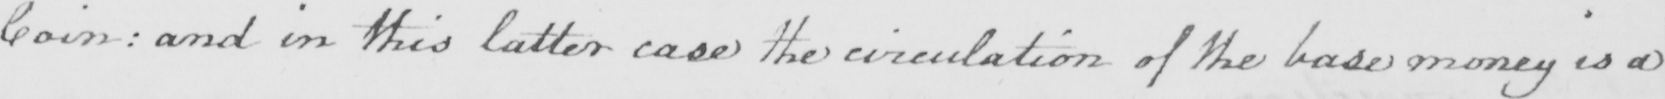Can you tell me what this handwritten text says? Coin :  and in this latter case the circulation of the base money is a 